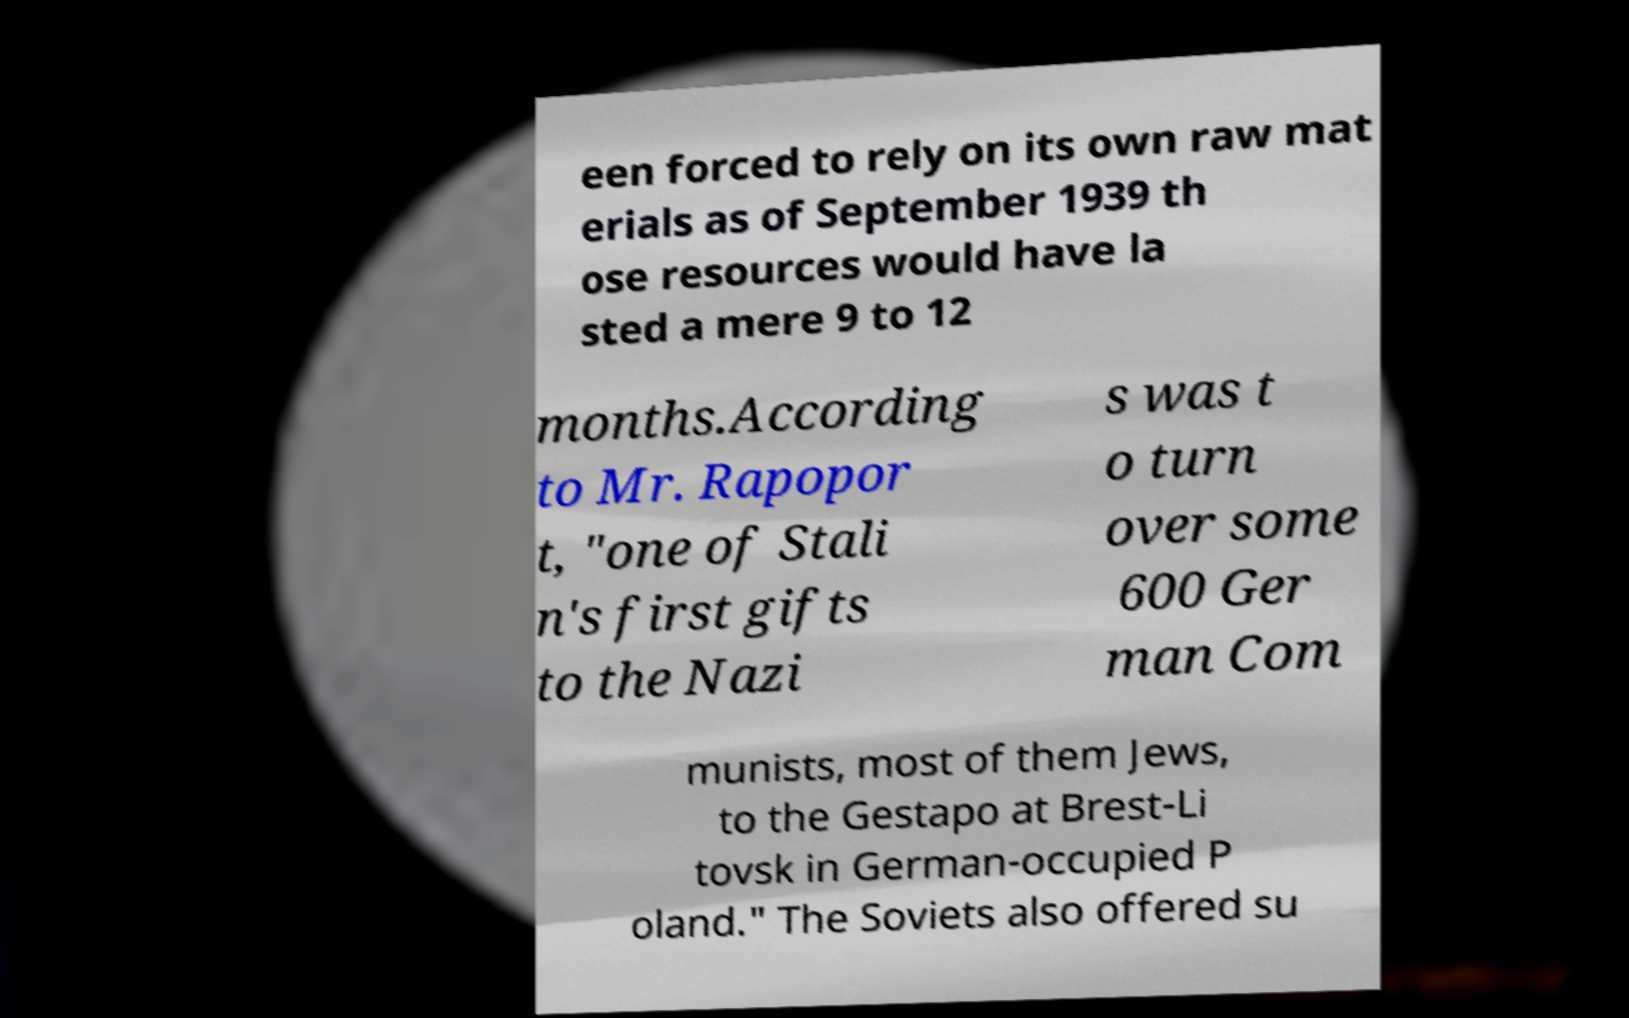There's text embedded in this image that I need extracted. Can you transcribe it verbatim? een forced to rely on its own raw mat erials as of September 1939 th ose resources would have la sted a mere 9 to 12 months.According to Mr. Rapopor t, "one of Stali n's first gifts to the Nazi s was t o turn over some 600 Ger man Com munists, most of them Jews, to the Gestapo at Brest-Li tovsk in German-occupied P oland." The Soviets also offered su 